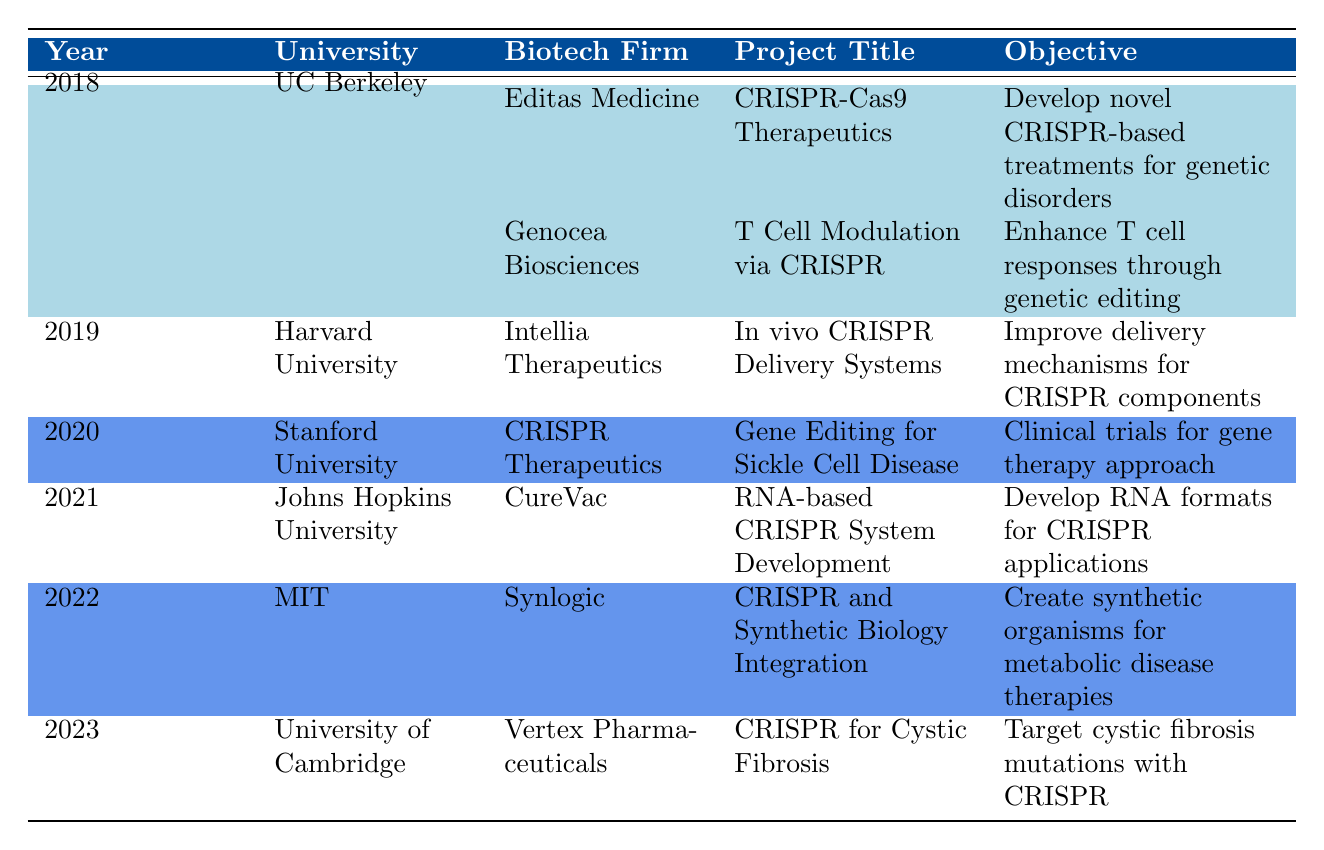What university collaborated with Editas Medicine in 2018? According to the table, UC Berkeley is the university that collaborated with Editas Medicine in 2018.
Answer: UC Berkeley Which project was focused on sickle cell disease? The project focused on sickle cell disease is titled "Gene Editing for Sickle Cell Disease," which involved Stanford University and CRISPR Therapeutics in 2020.
Answer: Gene Editing for Sickle Cell Disease Did any projects include a partnership in 2019? Yes, the partnership with Intellia Therapeutics in 2019 included an expansion of the partnership as an outcome.
Answer: Yes How many collaborative projects involved MIT from 2018 to 2023? From the table, it is clear that MIT had one collaborative project in 2022, namely with Synlogic for "CRISPR and Synthetic Biology Integration."
Answer: 1 Which year saw the initiation of phase I trials for gene therapy? The year that saw the initiation of phase I trials for gene therapy is 2020, as indicated by the project at Stanford University with CRISPR Therapeutics.
Answer: 2020 What is the objective of the project titled "CRISPR for Cystic Fibrosis"? The objective of the project titled "CRISPR for Cystic Fibrosis" is to target cystic fibrosis mutations with CRISPR, as stated in the table for 2023 with Vertex Pharmaceuticals.
Answer: Target cystic fibrosis mutations with CRISPR Which biotech firm was involved in the most projects across the years? To determine this, we note the biotech firms mentioned: Editas Medicine, Genocea Biosciences, Intellia Therapeutics, CRISPR Therapeutics, CureVac, Synlogic, and Vertex Pharmaceuticals. Each firm has one specific project involved, thus no single firm had more than one project.
Answer: None (all firms had one project each) What was the outcome of the project by Johns Hopkins University in 2021? The outcomes of the project by Johns Hopkins University with CureVac in 2021 included a research paper being published and further research funding obtained.
Answer: Research paper published; further research funding obtained What was the project objective of the collaboration between UC Berkeley and Genocea Biosciences? The objective of the collaboration between UC Berkeley and Genocea Biosciences is to enhance T cell responses through genetic editing, as indicated for the project "T Cell Modulation via CRISPR" in 2018.
Answer: Enhance T cell responses through genetic editing 